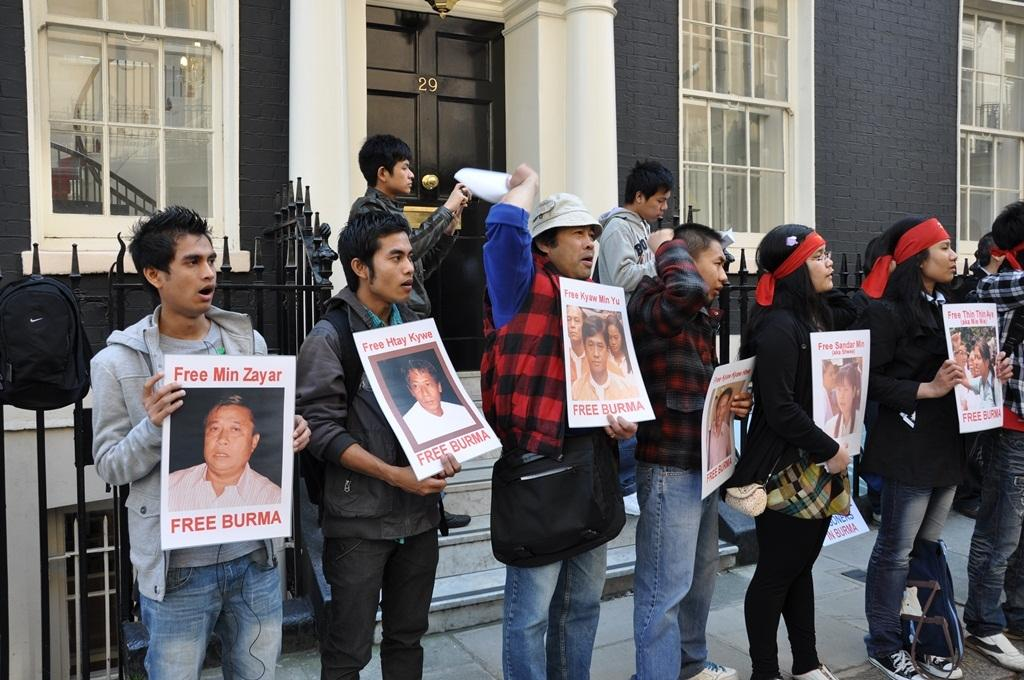What is the main subject of the image? The main subject of the image is a group of people. What are some of the people holding in the image? Some people are holding placards in the image. What type of material can be seen in the image? Metal rods are visible in the image. What architectural features can be seen in the image? There are windows and a building in the image. What type of attack can be seen happening in the image? There is no attack present in the image; it features a group of people holding placards. How many clocks are visible in the image? There are no clocks visible in the image. 